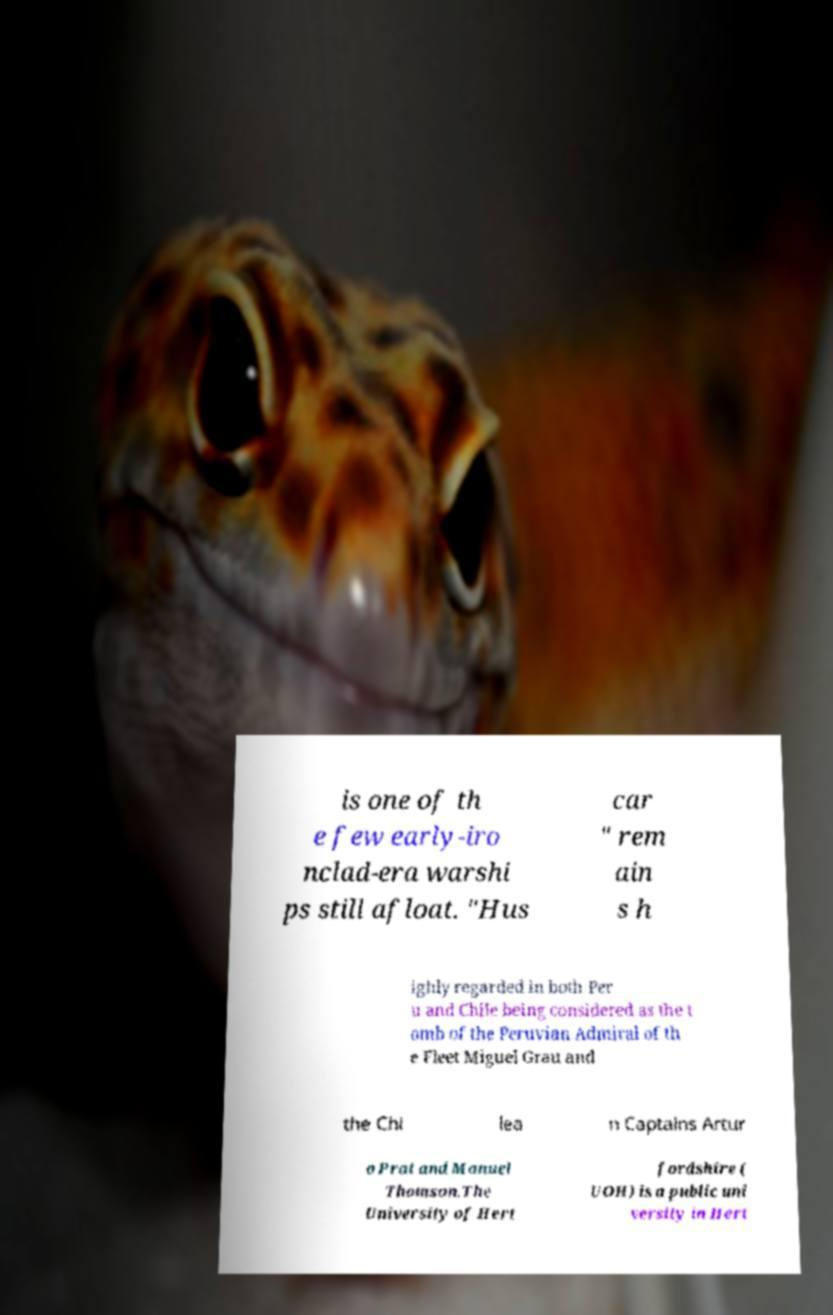What messages or text are displayed in this image? I need them in a readable, typed format. is one of th e few early-iro nclad-era warshi ps still afloat. "Hus car " rem ain s h ighly regarded in both Per u and Chile being considered as the t omb of the Peruvian Admiral of th e Fleet Miguel Grau and the Chi lea n Captains Artur o Prat and Manuel Thomson.The University of Hert fordshire ( UOH) is a public uni versity in Hert 